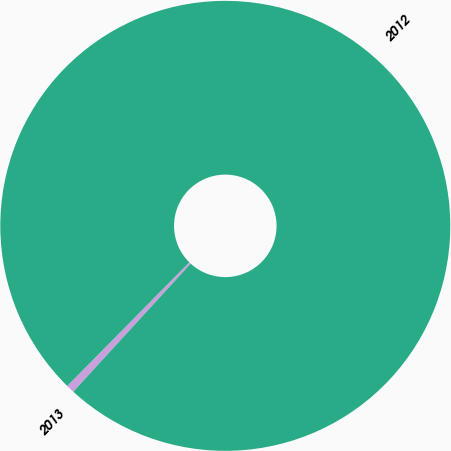<chart> <loc_0><loc_0><loc_500><loc_500><pie_chart><fcel>2013<fcel>2012<nl><fcel>0.59%<fcel>99.41%<nl></chart> 